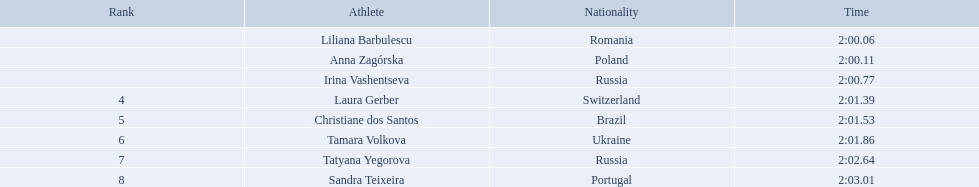Who were the athletes? Liliana Barbulescu, 2:00.06, Anna Zagórska, 2:00.11, Irina Vashentseva, 2:00.77, Laura Gerber, 2:01.39, Christiane dos Santos, 2:01.53, Tamara Volkova, 2:01.86, Tatyana Yegorova, 2:02.64, Sandra Teixeira, 2:03.01. Who received 2nd place? Anna Zagórska, 2:00.11. What was her time? 2:00.11. Who came in second place at the athletics at the 2003 summer universiade - women's 800 metres? Anna Zagórska. What was her time? 2:00.11. What are the names of the competitors? Liliana Barbulescu, Anna Zagórska, Irina Vashentseva, Laura Gerber, Christiane dos Santos, Tamara Volkova, Tatyana Yegorova, Sandra Teixeira. Which finalist finished the fastest? Liliana Barbulescu. Give me the full table as a dictionary. {'header': ['Rank', 'Athlete', 'Nationality', 'Time'], 'rows': [['', 'Liliana Barbulescu', 'Romania', '2:00.06'], ['', 'Anna Zagórska', 'Poland', '2:00.11'], ['', 'Irina Vashentseva', 'Russia', '2:00.77'], ['4', 'Laura Gerber', 'Switzerland', '2:01.39'], ['5', 'Christiane dos Santos', 'Brazil', '2:01.53'], ['6', 'Tamara Volkova', 'Ukraine', '2:01.86'], ['7', 'Tatyana Yegorova', 'Russia', '2:02.64'], ['8', 'Sandra Teixeira', 'Portugal', '2:03.01']]} What were all the finishing times? 2:00.06, 2:00.11, 2:00.77, 2:01.39, 2:01.53, 2:01.86, 2:02.64, 2:03.01. Which of these is anna zagorska's? 2:00.11. Who were the athlete were in the athletics at the 2003 summer universiade - women's 800 metres? , Liliana Barbulescu, Anna Zagórska, Irina Vashentseva, Laura Gerber, Christiane dos Santos, Tamara Volkova, Tatyana Yegorova, Sandra Teixeira. What was anna zagorska finishing time? 2:00.11. What athletes are in the top five for the women's 800 metres? Liliana Barbulescu, Anna Zagórska, Irina Vashentseva, Laura Gerber, Christiane dos Santos. Which athletes are in the top 3? Liliana Barbulescu, Anna Zagórska, Irina Vashentseva. Who is the second place runner in the women's 800 metres? Anna Zagórska. What is the second place runner's time? 2:00.11. What were all the final times? 2:00.06, 2:00.11, 2:00.77, 2:01.39, 2:01.53, 2:01.86, 2:02.64, 2:03.01. Which of these is attributed to anna zagorska? 2:00.11. Who were all the competitors? Liliana Barbulescu, Anna Zagórska, Irina Vashentseva, Laura Gerber, Christiane dos Santos, Tamara Volkova, Tatyana Yegorova, Sandra Teixeira. What were their final times? 2:00.06, 2:00.11, 2:00.77, 2:01.39, 2:01.53, 2:01.86, 2:02.64, 2:03.01. Which contestant finished soonest? Liliana Barbulescu. Who were the sportswomen participating in the athletics at the 2003 summer universiade - women's 800 meters? , Liliana Barbulescu, Anna Zagórska, Irina Vashentseva, Laura Gerber, Christiane dos Santos, Tamara Volkova, Tatyana Yegorova, Sandra Teixeira. What was anna zagorska's completion time? 2:00.11. Who were the participants in the athletics at the 2003 summer universiade - women's 800 meters? , Liliana Barbulescu, Anna Zagórska, Irina Vashentseva, Laura Gerber, Christiane dos Santos, Tamara Volkova, Tatyana Yegorova, Sandra Teixeira. What was anna zagorska's finishing duration? 2:00.11. Can you name the athletes? Liliana Barbulescu, 2:00.06, Anna Zagórska, 2:00.11, Irina Vashentseva, 2:00.77, Laura Gerber, 2:01.39, Christiane dos Santos, 2:01.53, Tamara Volkova, 2:01.86, Tatyana Yegorova, 2:02.64, Sandra Teixeira, 2:03.01. Who came in second place? Anna Zagórska, 2:00.11. What was her finishing time? 2:00.11. Who are the athletes involved in the competition? Liliana Barbulescu, Anna Zagórska, Irina Vashentseva, Laura Gerber, Christiane dos Santos, Tamara Volkova, Tatyana Yegorova, Sandra Teixeira. What were each of their times during the heat? 2:00.06, 2:00.11, 2:00.77, 2:01.39, 2:01.53, 2:01.86, 2:02.64, 2:03.01. Which of these times is the quickest? 2:00.06. Which athlete holds this record time? Liliana Barbulescu. Who were the participants in the athletic event? Liliana Barbulescu, Anna Zagórska, Irina Vashentseva, Laura Gerber, Christiane dos Santos, Tamara Volkova, Tatyana Yegorova, Sandra Teixeira. What were their completion times? 2:00.06, 2:00.11, 2:00.77, 2:01.39, 2:01.53, 2:01.86, 2:02.64, 2:03.01. Which competitor finished first? Liliana Barbulescu. In the women's 800 meters at the 2003 summer universiade, which athletes were competing? , Liliana Barbulescu, Anna Zagórska, Irina Vashentseva, Laura Gerber, Christiane dos Santos, Tamara Volkova, Tatyana Yegorova, Sandra Teixeira. What was the finishing time for anna zagorska? 2:00.11. 